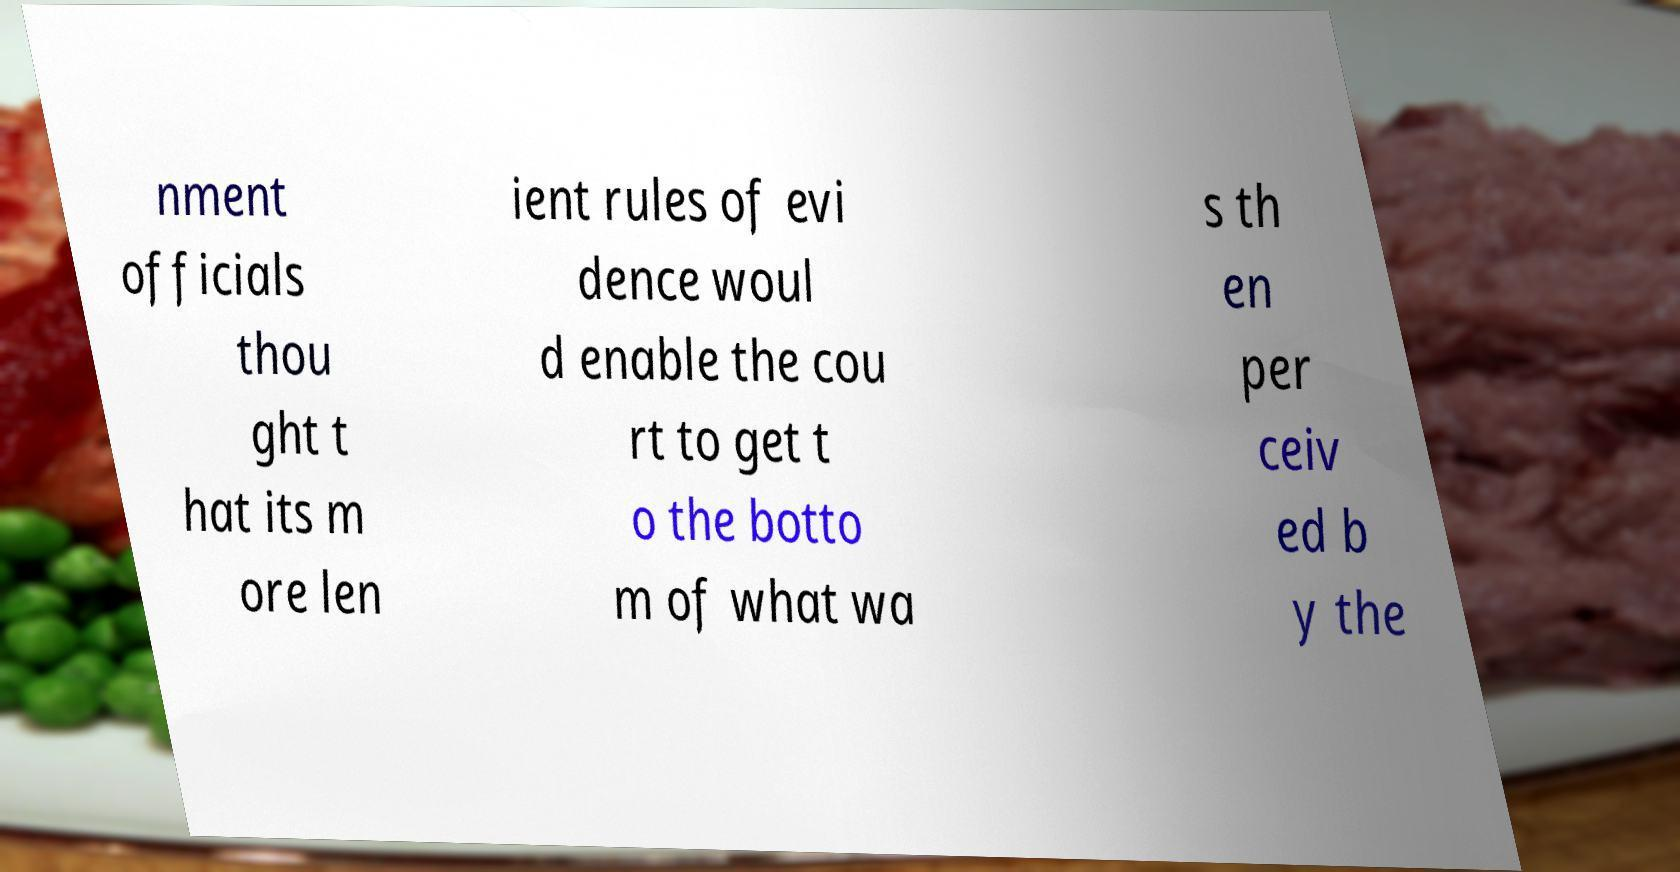Can you read and provide the text displayed in the image?This photo seems to have some interesting text. Can you extract and type it out for me? nment officials thou ght t hat its m ore len ient rules of evi dence woul d enable the cou rt to get t o the botto m of what wa s th en per ceiv ed b y the 